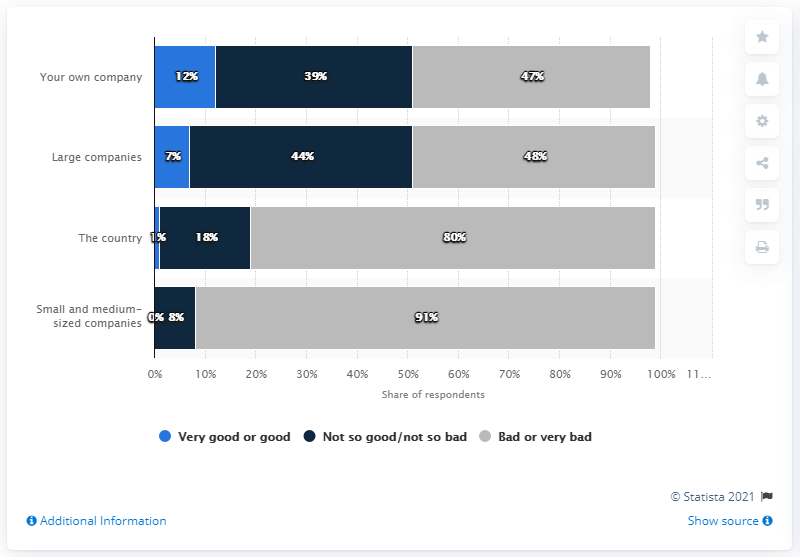Highlight a few significant elements in this photo. According to the survey conducted in Chile, 80% of the respondents predicted that the country's economy would be in a poor or very poor state six months after the COVID-19 pandemic. According to a survey of businesspeople, 91% believed that their economic situation would deteriorate after the COVID-19 crisis. 